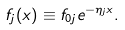<formula> <loc_0><loc_0><loc_500><loc_500>f _ { j } ( x ) \equiv f _ { 0 j } e ^ { - \eta _ { j } x } .</formula> 